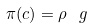<formula> <loc_0><loc_0><loc_500><loc_500>\pi ( c ) = \rho \, \ g</formula> 